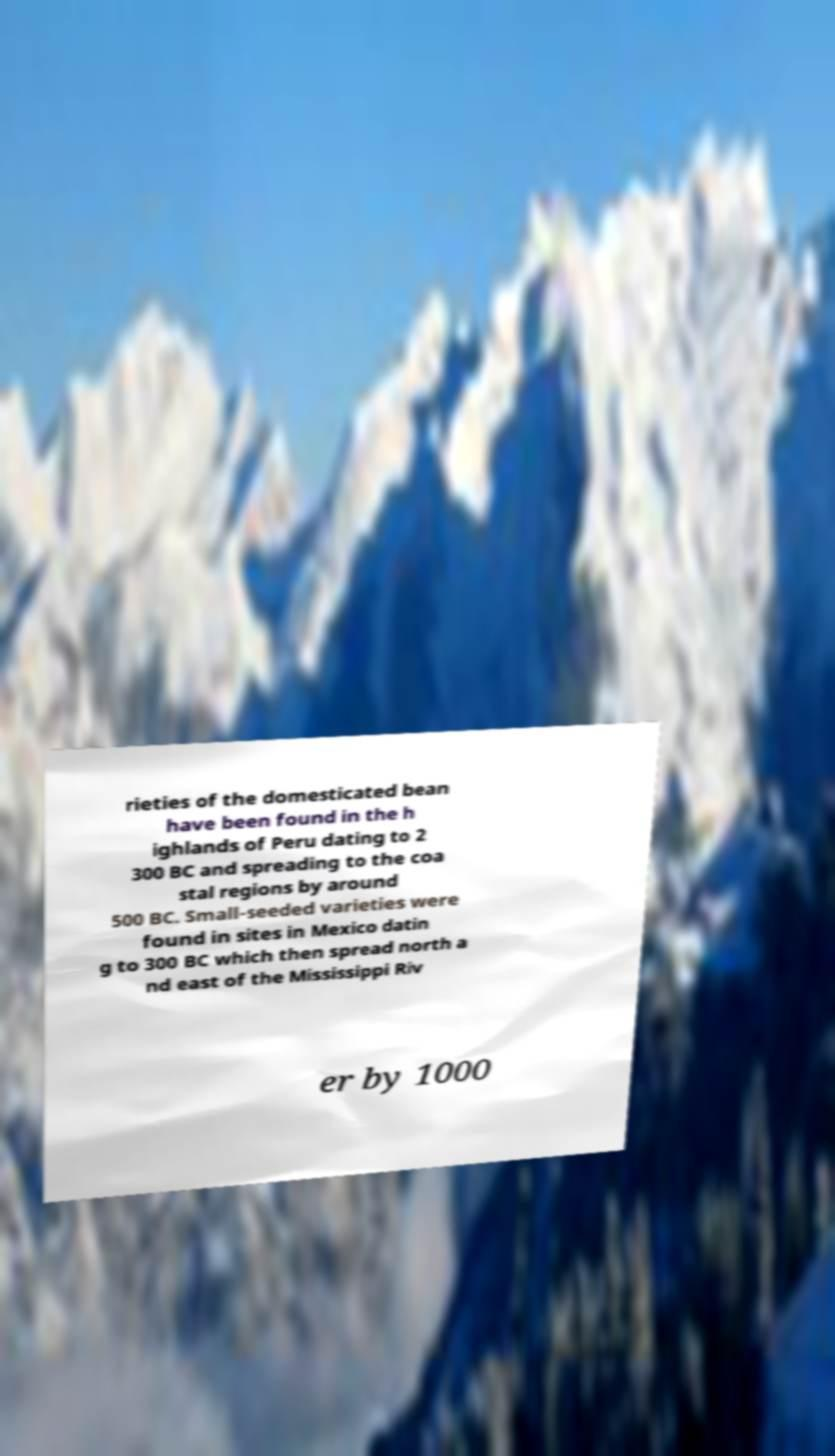For documentation purposes, I need the text within this image transcribed. Could you provide that? rieties of the domesticated bean have been found in the h ighlands of Peru dating to 2 300 BC and spreading to the coa stal regions by around 500 BC. Small-seeded varieties were found in sites in Mexico datin g to 300 BC which then spread north a nd east of the Mississippi Riv er by 1000 